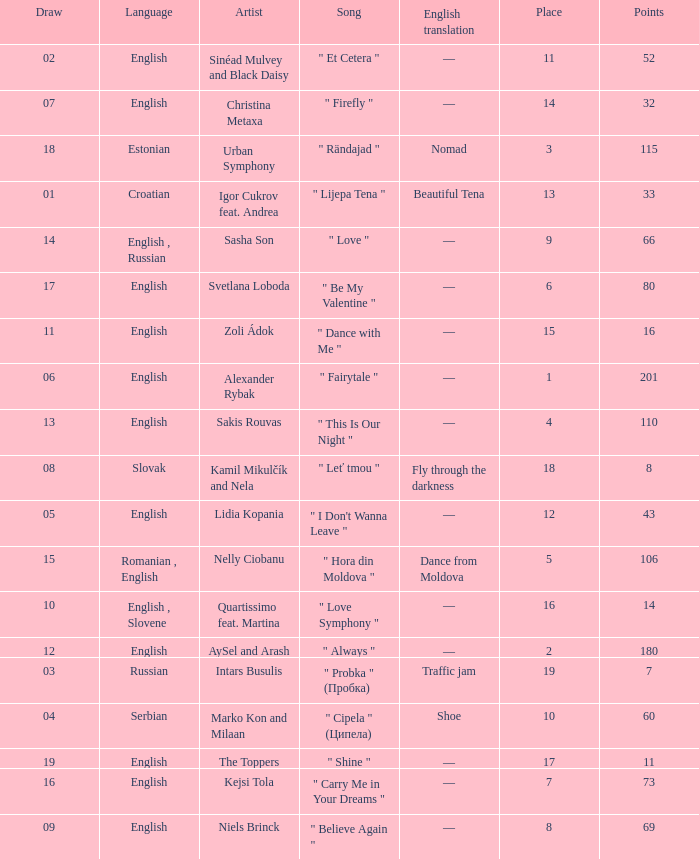What is the place when the draw is less than 12 and the artist is quartissimo feat. martina? 16.0. 